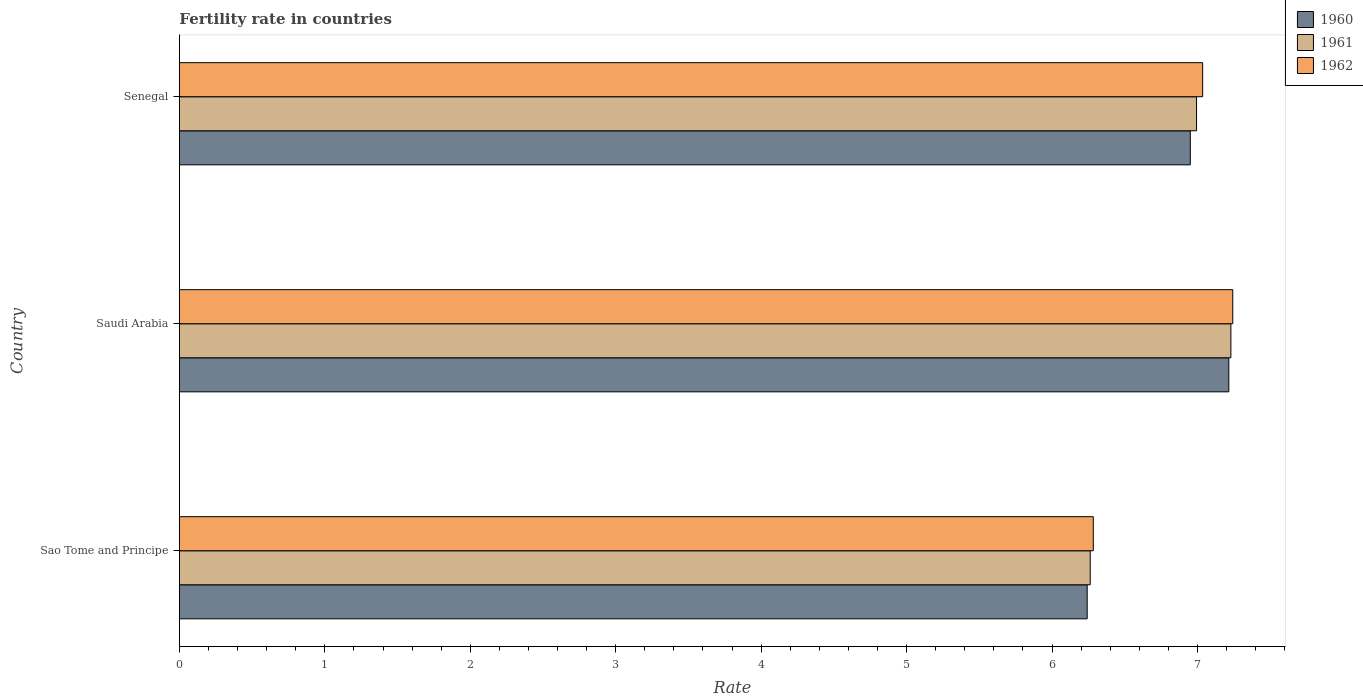How many different coloured bars are there?
Provide a succinct answer. 3. Are the number of bars on each tick of the Y-axis equal?
Make the answer very short. Yes. How many bars are there on the 1st tick from the top?
Offer a very short reply. 3. What is the label of the 1st group of bars from the top?
Keep it short and to the point. Senegal. What is the fertility rate in 1960 in Senegal?
Ensure brevity in your answer.  6.95. Across all countries, what is the maximum fertility rate in 1961?
Provide a short and direct response. 7.23. Across all countries, what is the minimum fertility rate in 1962?
Keep it short and to the point. 6.28. In which country was the fertility rate in 1961 maximum?
Provide a succinct answer. Saudi Arabia. In which country was the fertility rate in 1960 minimum?
Ensure brevity in your answer.  Sao Tome and Principe. What is the total fertility rate in 1962 in the graph?
Your response must be concise. 20.56. What is the difference between the fertility rate in 1960 in Sao Tome and Principe and that in Senegal?
Ensure brevity in your answer.  -0.71. What is the difference between the fertility rate in 1960 in Saudi Arabia and the fertility rate in 1962 in Sao Tome and Principe?
Offer a very short reply. 0.93. What is the average fertility rate in 1960 per country?
Your answer should be very brief. 6.8. What is the difference between the fertility rate in 1960 and fertility rate in 1962 in Saudi Arabia?
Ensure brevity in your answer.  -0.03. What is the ratio of the fertility rate in 1960 in Sao Tome and Principe to that in Saudi Arabia?
Your answer should be compact. 0.87. Is the fertility rate in 1961 in Sao Tome and Principe less than that in Senegal?
Your response must be concise. Yes. Is the difference between the fertility rate in 1960 in Sao Tome and Principe and Senegal greater than the difference between the fertility rate in 1962 in Sao Tome and Principe and Senegal?
Provide a succinct answer. Yes. What is the difference between the highest and the second highest fertility rate in 1960?
Provide a succinct answer. 0.26. What is the difference between the highest and the lowest fertility rate in 1962?
Your answer should be very brief. 0.96. Is it the case that in every country, the sum of the fertility rate in 1960 and fertility rate in 1962 is greater than the fertility rate in 1961?
Make the answer very short. Yes. How many countries are there in the graph?
Keep it short and to the point. 3. What is the difference between two consecutive major ticks on the X-axis?
Keep it short and to the point. 1. Are the values on the major ticks of X-axis written in scientific E-notation?
Your answer should be very brief. No. Does the graph contain any zero values?
Ensure brevity in your answer.  No. Where does the legend appear in the graph?
Offer a terse response. Top right. How many legend labels are there?
Offer a terse response. 3. What is the title of the graph?
Your answer should be very brief. Fertility rate in countries. What is the label or title of the X-axis?
Offer a very short reply. Rate. What is the label or title of the Y-axis?
Provide a short and direct response. Country. What is the Rate in 1960 in Sao Tome and Principe?
Your answer should be compact. 6.24. What is the Rate in 1961 in Sao Tome and Principe?
Offer a very short reply. 6.26. What is the Rate of 1962 in Sao Tome and Principe?
Give a very brief answer. 6.28. What is the Rate of 1960 in Saudi Arabia?
Make the answer very short. 7.22. What is the Rate in 1961 in Saudi Arabia?
Your response must be concise. 7.23. What is the Rate of 1962 in Saudi Arabia?
Give a very brief answer. 7.24. What is the Rate of 1960 in Senegal?
Your response must be concise. 6.95. What is the Rate of 1961 in Senegal?
Provide a short and direct response. 6.99. What is the Rate of 1962 in Senegal?
Your answer should be compact. 7.04. Across all countries, what is the maximum Rate in 1960?
Your response must be concise. 7.22. Across all countries, what is the maximum Rate of 1961?
Offer a very short reply. 7.23. Across all countries, what is the maximum Rate of 1962?
Ensure brevity in your answer.  7.24. Across all countries, what is the minimum Rate of 1960?
Offer a terse response. 6.24. Across all countries, what is the minimum Rate of 1961?
Give a very brief answer. 6.26. Across all countries, what is the minimum Rate of 1962?
Provide a short and direct response. 6.28. What is the total Rate in 1960 in the graph?
Keep it short and to the point. 20.41. What is the total Rate in 1961 in the graph?
Keep it short and to the point. 20.49. What is the total Rate of 1962 in the graph?
Ensure brevity in your answer.  20.56. What is the difference between the Rate in 1960 in Sao Tome and Principe and that in Saudi Arabia?
Your answer should be compact. -0.97. What is the difference between the Rate of 1961 in Sao Tome and Principe and that in Saudi Arabia?
Make the answer very short. -0.97. What is the difference between the Rate in 1962 in Sao Tome and Principe and that in Saudi Arabia?
Provide a short and direct response. -0.96. What is the difference between the Rate of 1960 in Sao Tome and Principe and that in Senegal?
Ensure brevity in your answer.  -0.71. What is the difference between the Rate in 1961 in Sao Tome and Principe and that in Senegal?
Provide a short and direct response. -0.73. What is the difference between the Rate in 1962 in Sao Tome and Principe and that in Senegal?
Offer a terse response. -0.75. What is the difference between the Rate in 1960 in Saudi Arabia and that in Senegal?
Provide a short and direct response. 0.27. What is the difference between the Rate of 1961 in Saudi Arabia and that in Senegal?
Your answer should be very brief. 0.24. What is the difference between the Rate of 1962 in Saudi Arabia and that in Senegal?
Offer a terse response. 0.21. What is the difference between the Rate in 1960 in Sao Tome and Principe and the Rate in 1961 in Saudi Arabia?
Provide a short and direct response. -0.99. What is the difference between the Rate of 1960 in Sao Tome and Principe and the Rate of 1962 in Saudi Arabia?
Provide a succinct answer. -1. What is the difference between the Rate of 1961 in Sao Tome and Principe and the Rate of 1962 in Saudi Arabia?
Keep it short and to the point. -0.98. What is the difference between the Rate in 1960 in Sao Tome and Principe and the Rate in 1961 in Senegal?
Make the answer very short. -0.75. What is the difference between the Rate in 1960 in Sao Tome and Principe and the Rate in 1962 in Senegal?
Your answer should be very brief. -0.79. What is the difference between the Rate of 1961 in Sao Tome and Principe and the Rate of 1962 in Senegal?
Make the answer very short. -0.77. What is the difference between the Rate in 1960 in Saudi Arabia and the Rate in 1961 in Senegal?
Offer a very short reply. 0.22. What is the difference between the Rate in 1960 in Saudi Arabia and the Rate in 1962 in Senegal?
Offer a very short reply. 0.18. What is the difference between the Rate of 1961 in Saudi Arabia and the Rate of 1962 in Senegal?
Keep it short and to the point. 0.19. What is the average Rate of 1960 per country?
Offer a terse response. 6.8. What is the average Rate of 1961 per country?
Make the answer very short. 6.83. What is the average Rate of 1962 per country?
Give a very brief answer. 6.85. What is the difference between the Rate in 1960 and Rate in 1961 in Sao Tome and Principe?
Your response must be concise. -0.02. What is the difference between the Rate of 1960 and Rate of 1962 in Sao Tome and Principe?
Make the answer very short. -0.04. What is the difference between the Rate of 1961 and Rate of 1962 in Sao Tome and Principe?
Offer a very short reply. -0.02. What is the difference between the Rate of 1960 and Rate of 1961 in Saudi Arabia?
Your answer should be compact. -0.01. What is the difference between the Rate in 1960 and Rate in 1962 in Saudi Arabia?
Your answer should be very brief. -0.03. What is the difference between the Rate in 1961 and Rate in 1962 in Saudi Arabia?
Your response must be concise. -0.01. What is the difference between the Rate of 1960 and Rate of 1961 in Senegal?
Your response must be concise. -0.04. What is the difference between the Rate in 1960 and Rate in 1962 in Senegal?
Ensure brevity in your answer.  -0.09. What is the difference between the Rate in 1961 and Rate in 1962 in Senegal?
Your response must be concise. -0.04. What is the ratio of the Rate in 1960 in Sao Tome and Principe to that in Saudi Arabia?
Your response must be concise. 0.86. What is the ratio of the Rate of 1961 in Sao Tome and Principe to that in Saudi Arabia?
Provide a succinct answer. 0.87. What is the ratio of the Rate in 1962 in Sao Tome and Principe to that in Saudi Arabia?
Offer a very short reply. 0.87. What is the ratio of the Rate in 1960 in Sao Tome and Principe to that in Senegal?
Your answer should be compact. 0.9. What is the ratio of the Rate of 1961 in Sao Tome and Principe to that in Senegal?
Make the answer very short. 0.9. What is the ratio of the Rate in 1962 in Sao Tome and Principe to that in Senegal?
Your answer should be very brief. 0.89. What is the ratio of the Rate of 1960 in Saudi Arabia to that in Senegal?
Ensure brevity in your answer.  1.04. What is the ratio of the Rate of 1961 in Saudi Arabia to that in Senegal?
Your response must be concise. 1.03. What is the ratio of the Rate in 1962 in Saudi Arabia to that in Senegal?
Ensure brevity in your answer.  1.03. What is the difference between the highest and the second highest Rate in 1960?
Provide a succinct answer. 0.27. What is the difference between the highest and the second highest Rate of 1961?
Offer a very short reply. 0.24. What is the difference between the highest and the second highest Rate in 1962?
Offer a very short reply. 0.21. What is the difference between the highest and the lowest Rate of 1962?
Offer a very short reply. 0.96. 